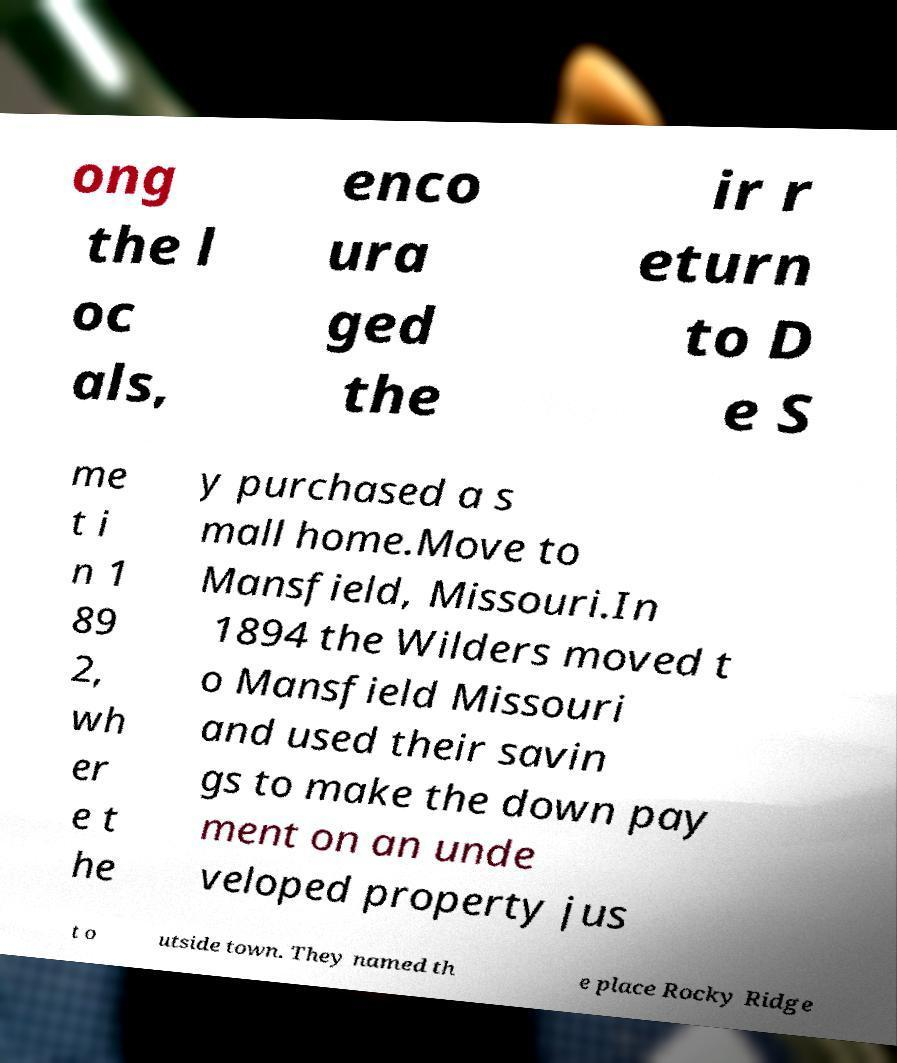Could you assist in decoding the text presented in this image and type it out clearly? ong the l oc als, enco ura ged the ir r eturn to D e S me t i n 1 89 2, wh er e t he y purchased a s mall home.Move to Mansfield, Missouri.In 1894 the Wilders moved t o Mansfield Missouri and used their savin gs to make the down pay ment on an unde veloped property jus t o utside town. They named th e place Rocky Ridge 